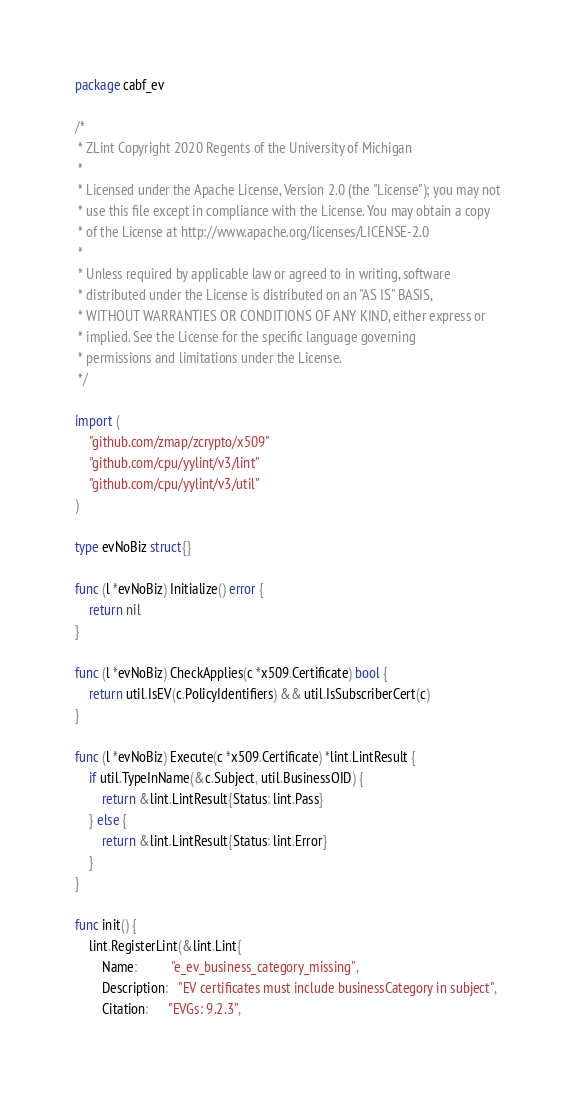Convert code to text. <code><loc_0><loc_0><loc_500><loc_500><_Go_>package cabf_ev

/*
 * ZLint Copyright 2020 Regents of the University of Michigan
 *
 * Licensed under the Apache License, Version 2.0 (the "License"); you may not
 * use this file except in compliance with the License. You may obtain a copy
 * of the License at http://www.apache.org/licenses/LICENSE-2.0
 *
 * Unless required by applicable law or agreed to in writing, software
 * distributed under the License is distributed on an "AS IS" BASIS,
 * WITHOUT WARRANTIES OR CONDITIONS OF ANY KIND, either express or
 * implied. See the License for the specific language governing
 * permissions and limitations under the License.
 */

import (
	"github.com/zmap/zcrypto/x509"
	"github.com/cpu/yylint/v3/lint"
	"github.com/cpu/yylint/v3/util"
)

type evNoBiz struct{}

func (l *evNoBiz) Initialize() error {
	return nil
}

func (l *evNoBiz) CheckApplies(c *x509.Certificate) bool {
	return util.IsEV(c.PolicyIdentifiers) && util.IsSubscriberCert(c)
}

func (l *evNoBiz) Execute(c *x509.Certificate) *lint.LintResult {
	if util.TypeInName(&c.Subject, util.BusinessOID) {
		return &lint.LintResult{Status: lint.Pass}
	} else {
		return &lint.LintResult{Status: lint.Error}
	}
}

func init() {
	lint.RegisterLint(&lint.Lint{
		Name:          "e_ev_business_category_missing",
		Description:   "EV certificates must include businessCategory in subject",
		Citation:      "EVGs: 9.2.3",</code> 